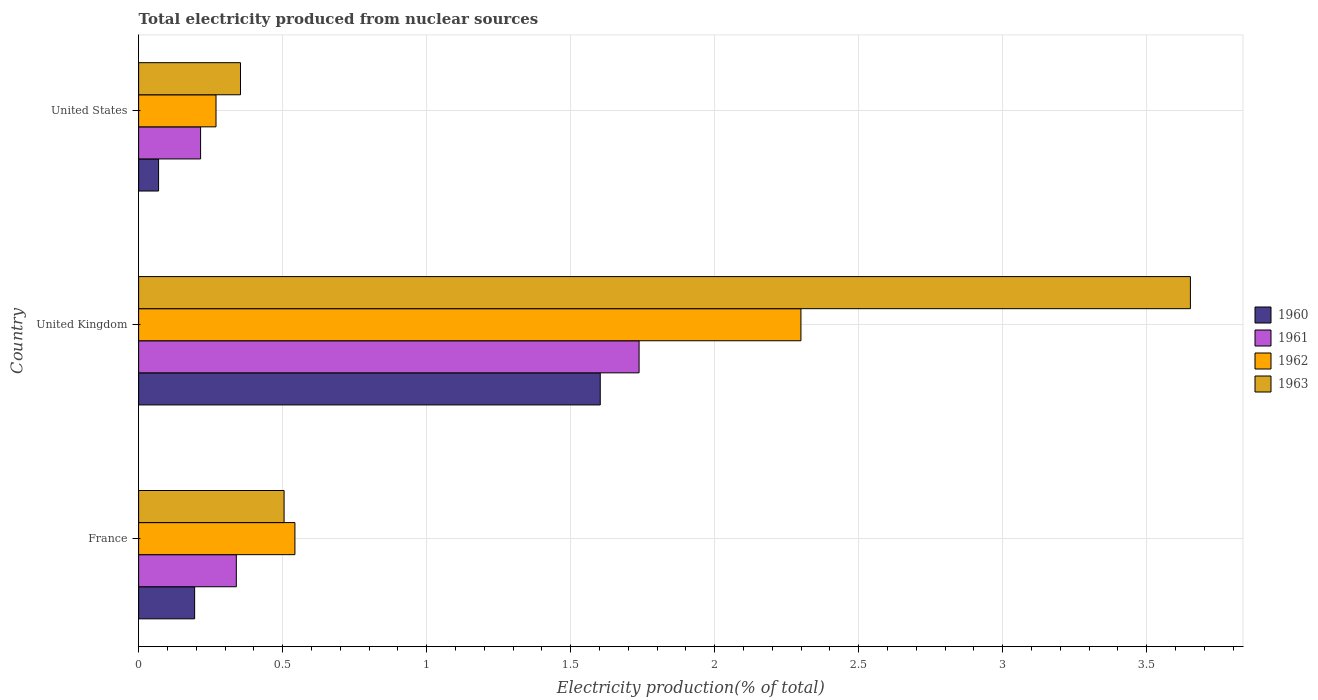How many different coloured bars are there?
Ensure brevity in your answer.  4. Are the number of bars per tick equal to the number of legend labels?
Provide a succinct answer. Yes. Are the number of bars on each tick of the Y-axis equal?
Ensure brevity in your answer.  Yes. How many bars are there on the 3rd tick from the top?
Make the answer very short. 4. What is the label of the 1st group of bars from the top?
Your answer should be very brief. United States. What is the total electricity produced in 1961 in United Kingdom?
Ensure brevity in your answer.  1.74. Across all countries, what is the maximum total electricity produced in 1961?
Give a very brief answer. 1.74. Across all countries, what is the minimum total electricity produced in 1961?
Ensure brevity in your answer.  0.22. In which country was the total electricity produced in 1963 minimum?
Make the answer very short. United States. What is the total total electricity produced in 1963 in the graph?
Your answer should be compact. 4.51. What is the difference between the total electricity produced in 1963 in France and that in United States?
Provide a succinct answer. 0.15. What is the difference between the total electricity produced in 1961 in United States and the total electricity produced in 1962 in United Kingdom?
Ensure brevity in your answer.  -2.08. What is the average total electricity produced in 1963 per country?
Provide a short and direct response. 1.5. What is the difference between the total electricity produced in 1962 and total electricity produced in 1960 in United States?
Provide a short and direct response. 0.2. What is the ratio of the total electricity produced in 1962 in France to that in United States?
Your response must be concise. 2.02. Is the total electricity produced in 1960 in United Kingdom less than that in United States?
Offer a terse response. No. What is the difference between the highest and the second highest total electricity produced in 1960?
Ensure brevity in your answer.  1.41. What is the difference between the highest and the lowest total electricity produced in 1961?
Your answer should be compact. 1.52. In how many countries, is the total electricity produced in 1962 greater than the average total electricity produced in 1962 taken over all countries?
Offer a terse response. 1. Is it the case that in every country, the sum of the total electricity produced in 1961 and total electricity produced in 1960 is greater than the sum of total electricity produced in 1962 and total electricity produced in 1963?
Your answer should be compact. No. What does the 3rd bar from the top in United States represents?
Provide a short and direct response. 1961. What does the 2nd bar from the bottom in United Kingdom represents?
Provide a succinct answer. 1961. Is it the case that in every country, the sum of the total electricity produced in 1962 and total electricity produced in 1963 is greater than the total electricity produced in 1961?
Your response must be concise. Yes. How many countries are there in the graph?
Keep it short and to the point. 3. Are the values on the major ticks of X-axis written in scientific E-notation?
Keep it short and to the point. No. How many legend labels are there?
Your answer should be compact. 4. How are the legend labels stacked?
Provide a succinct answer. Vertical. What is the title of the graph?
Keep it short and to the point. Total electricity produced from nuclear sources. What is the label or title of the Y-axis?
Keep it short and to the point. Country. What is the Electricity production(% of total) of 1960 in France?
Offer a very short reply. 0.19. What is the Electricity production(% of total) of 1961 in France?
Offer a very short reply. 0.34. What is the Electricity production(% of total) of 1962 in France?
Keep it short and to the point. 0.54. What is the Electricity production(% of total) of 1963 in France?
Offer a terse response. 0.51. What is the Electricity production(% of total) of 1960 in United Kingdom?
Your response must be concise. 1.6. What is the Electricity production(% of total) of 1961 in United Kingdom?
Offer a terse response. 1.74. What is the Electricity production(% of total) in 1962 in United Kingdom?
Offer a terse response. 2.3. What is the Electricity production(% of total) of 1963 in United Kingdom?
Keep it short and to the point. 3.65. What is the Electricity production(% of total) of 1960 in United States?
Offer a very short reply. 0.07. What is the Electricity production(% of total) in 1961 in United States?
Make the answer very short. 0.22. What is the Electricity production(% of total) of 1962 in United States?
Give a very brief answer. 0.27. What is the Electricity production(% of total) of 1963 in United States?
Your answer should be compact. 0.35. Across all countries, what is the maximum Electricity production(% of total) in 1960?
Provide a short and direct response. 1.6. Across all countries, what is the maximum Electricity production(% of total) of 1961?
Your response must be concise. 1.74. Across all countries, what is the maximum Electricity production(% of total) of 1962?
Keep it short and to the point. 2.3. Across all countries, what is the maximum Electricity production(% of total) in 1963?
Give a very brief answer. 3.65. Across all countries, what is the minimum Electricity production(% of total) of 1960?
Keep it short and to the point. 0.07. Across all countries, what is the minimum Electricity production(% of total) in 1961?
Give a very brief answer. 0.22. Across all countries, what is the minimum Electricity production(% of total) in 1962?
Ensure brevity in your answer.  0.27. Across all countries, what is the minimum Electricity production(% of total) in 1963?
Provide a succinct answer. 0.35. What is the total Electricity production(% of total) of 1960 in the graph?
Make the answer very short. 1.87. What is the total Electricity production(% of total) in 1961 in the graph?
Ensure brevity in your answer.  2.29. What is the total Electricity production(% of total) of 1962 in the graph?
Your answer should be compact. 3.11. What is the total Electricity production(% of total) in 1963 in the graph?
Your answer should be compact. 4.51. What is the difference between the Electricity production(% of total) of 1960 in France and that in United Kingdom?
Keep it short and to the point. -1.41. What is the difference between the Electricity production(% of total) of 1961 in France and that in United Kingdom?
Your answer should be very brief. -1.4. What is the difference between the Electricity production(% of total) of 1962 in France and that in United Kingdom?
Make the answer very short. -1.76. What is the difference between the Electricity production(% of total) of 1963 in France and that in United Kingdom?
Offer a terse response. -3.15. What is the difference between the Electricity production(% of total) in 1960 in France and that in United States?
Offer a very short reply. 0.13. What is the difference between the Electricity production(% of total) in 1961 in France and that in United States?
Offer a very short reply. 0.12. What is the difference between the Electricity production(% of total) of 1962 in France and that in United States?
Ensure brevity in your answer.  0.27. What is the difference between the Electricity production(% of total) of 1963 in France and that in United States?
Offer a terse response. 0.15. What is the difference between the Electricity production(% of total) in 1960 in United Kingdom and that in United States?
Your response must be concise. 1.53. What is the difference between the Electricity production(% of total) of 1961 in United Kingdom and that in United States?
Make the answer very short. 1.52. What is the difference between the Electricity production(% of total) in 1962 in United Kingdom and that in United States?
Offer a very short reply. 2.03. What is the difference between the Electricity production(% of total) in 1963 in United Kingdom and that in United States?
Your response must be concise. 3.3. What is the difference between the Electricity production(% of total) of 1960 in France and the Electricity production(% of total) of 1961 in United Kingdom?
Keep it short and to the point. -1.54. What is the difference between the Electricity production(% of total) in 1960 in France and the Electricity production(% of total) in 1962 in United Kingdom?
Offer a terse response. -2.11. What is the difference between the Electricity production(% of total) in 1960 in France and the Electricity production(% of total) in 1963 in United Kingdom?
Offer a terse response. -3.46. What is the difference between the Electricity production(% of total) in 1961 in France and the Electricity production(% of total) in 1962 in United Kingdom?
Offer a very short reply. -1.96. What is the difference between the Electricity production(% of total) in 1961 in France and the Electricity production(% of total) in 1963 in United Kingdom?
Give a very brief answer. -3.31. What is the difference between the Electricity production(% of total) of 1962 in France and the Electricity production(% of total) of 1963 in United Kingdom?
Keep it short and to the point. -3.11. What is the difference between the Electricity production(% of total) of 1960 in France and the Electricity production(% of total) of 1961 in United States?
Offer a very short reply. -0.02. What is the difference between the Electricity production(% of total) of 1960 in France and the Electricity production(% of total) of 1962 in United States?
Keep it short and to the point. -0.07. What is the difference between the Electricity production(% of total) of 1960 in France and the Electricity production(% of total) of 1963 in United States?
Your answer should be compact. -0.16. What is the difference between the Electricity production(% of total) of 1961 in France and the Electricity production(% of total) of 1962 in United States?
Provide a short and direct response. 0.07. What is the difference between the Electricity production(% of total) in 1961 in France and the Electricity production(% of total) in 1963 in United States?
Make the answer very short. -0.01. What is the difference between the Electricity production(% of total) in 1962 in France and the Electricity production(% of total) in 1963 in United States?
Make the answer very short. 0.19. What is the difference between the Electricity production(% of total) of 1960 in United Kingdom and the Electricity production(% of total) of 1961 in United States?
Keep it short and to the point. 1.39. What is the difference between the Electricity production(% of total) of 1960 in United Kingdom and the Electricity production(% of total) of 1962 in United States?
Your answer should be very brief. 1.33. What is the difference between the Electricity production(% of total) in 1960 in United Kingdom and the Electricity production(% of total) in 1963 in United States?
Offer a terse response. 1.25. What is the difference between the Electricity production(% of total) in 1961 in United Kingdom and the Electricity production(% of total) in 1962 in United States?
Your answer should be very brief. 1.47. What is the difference between the Electricity production(% of total) of 1961 in United Kingdom and the Electricity production(% of total) of 1963 in United States?
Provide a succinct answer. 1.38. What is the difference between the Electricity production(% of total) in 1962 in United Kingdom and the Electricity production(% of total) in 1963 in United States?
Offer a very short reply. 1.95. What is the average Electricity production(% of total) in 1960 per country?
Provide a short and direct response. 0.62. What is the average Electricity production(% of total) in 1961 per country?
Ensure brevity in your answer.  0.76. What is the average Electricity production(% of total) of 1963 per country?
Keep it short and to the point. 1.5. What is the difference between the Electricity production(% of total) in 1960 and Electricity production(% of total) in 1961 in France?
Offer a very short reply. -0.14. What is the difference between the Electricity production(% of total) of 1960 and Electricity production(% of total) of 1962 in France?
Give a very brief answer. -0.35. What is the difference between the Electricity production(% of total) in 1960 and Electricity production(% of total) in 1963 in France?
Offer a terse response. -0.31. What is the difference between the Electricity production(% of total) in 1961 and Electricity production(% of total) in 1962 in France?
Keep it short and to the point. -0.2. What is the difference between the Electricity production(% of total) in 1961 and Electricity production(% of total) in 1963 in France?
Your answer should be very brief. -0.17. What is the difference between the Electricity production(% of total) in 1962 and Electricity production(% of total) in 1963 in France?
Give a very brief answer. 0.04. What is the difference between the Electricity production(% of total) in 1960 and Electricity production(% of total) in 1961 in United Kingdom?
Your answer should be compact. -0.13. What is the difference between the Electricity production(% of total) of 1960 and Electricity production(% of total) of 1962 in United Kingdom?
Your response must be concise. -0.7. What is the difference between the Electricity production(% of total) of 1960 and Electricity production(% of total) of 1963 in United Kingdom?
Keep it short and to the point. -2.05. What is the difference between the Electricity production(% of total) in 1961 and Electricity production(% of total) in 1962 in United Kingdom?
Keep it short and to the point. -0.56. What is the difference between the Electricity production(% of total) in 1961 and Electricity production(% of total) in 1963 in United Kingdom?
Provide a succinct answer. -1.91. What is the difference between the Electricity production(% of total) of 1962 and Electricity production(% of total) of 1963 in United Kingdom?
Offer a very short reply. -1.35. What is the difference between the Electricity production(% of total) of 1960 and Electricity production(% of total) of 1961 in United States?
Your answer should be compact. -0.15. What is the difference between the Electricity production(% of total) of 1960 and Electricity production(% of total) of 1962 in United States?
Your answer should be compact. -0.2. What is the difference between the Electricity production(% of total) of 1960 and Electricity production(% of total) of 1963 in United States?
Offer a terse response. -0.28. What is the difference between the Electricity production(% of total) of 1961 and Electricity production(% of total) of 1962 in United States?
Keep it short and to the point. -0.05. What is the difference between the Electricity production(% of total) in 1961 and Electricity production(% of total) in 1963 in United States?
Your answer should be compact. -0.14. What is the difference between the Electricity production(% of total) in 1962 and Electricity production(% of total) in 1963 in United States?
Give a very brief answer. -0.09. What is the ratio of the Electricity production(% of total) in 1960 in France to that in United Kingdom?
Give a very brief answer. 0.12. What is the ratio of the Electricity production(% of total) in 1961 in France to that in United Kingdom?
Keep it short and to the point. 0.2. What is the ratio of the Electricity production(% of total) in 1962 in France to that in United Kingdom?
Give a very brief answer. 0.24. What is the ratio of the Electricity production(% of total) of 1963 in France to that in United Kingdom?
Provide a short and direct response. 0.14. What is the ratio of the Electricity production(% of total) of 1960 in France to that in United States?
Ensure brevity in your answer.  2.81. What is the ratio of the Electricity production(% of total) of 1961 in France to that in United States?
Make the answer very short. 1.58. What is the ratio of the Electricity production(% of total) in 1962 in France to that in United States?
Offer a very short reply. 2.02. What is the ratio of the Electricity production(% of total) of 1963 in France to that in United States?
Keep it short and to the point. 1.43. What is the ratio of the Electricity production(% of total) in 1960 in United Kingdom to that in United States?
Provide a short and direct response. 23.14. What is the ratio of the Electricity production(% of total) in 1961 in United Kingdom to that in United States?
Give a very brief answer. 8.08. What is the ratio of the Electricity production(% of total) in 1962 in United Kingdom to that in United States?
Your response must be concise. 8.56. What is the ratio of the Electricity production(% of total) of 1963 in United Kingdom to that in United States?
Your response must be concise. 10.32. What is the difference between the highest and the second highest Electricity production(% of total) in 1960?
Offer a very short reply. 1.41. What is the difference between the highest and the second highest Electricity production(% of total) of 1961?
Offer a terse response. 1.4. What is the difference between the highest and the second highest Electricity production(% of total) in 1962?
Keep it short and to the point. 1.76. What is the difference between the highest and the second highest Electricity production(% of total) of 1963?
Offer a very short reply. 3.15. What is the difference between the highest and the lowest Electricity production(% of total) in 1960?
Offer a terse response. 1.53. What is the difference between the highest and the lowest Electricity production(% of total) of 1961?
Make the answer very short. 1.52. What is the difference between the highest and the lowest Electricity production(% of total) of 1962?
Your answer should be compact. 2.03. What is the difference between the highest and the lowest Electricity production(% of total) in 1963?
Offer a terse response. 3.3. 